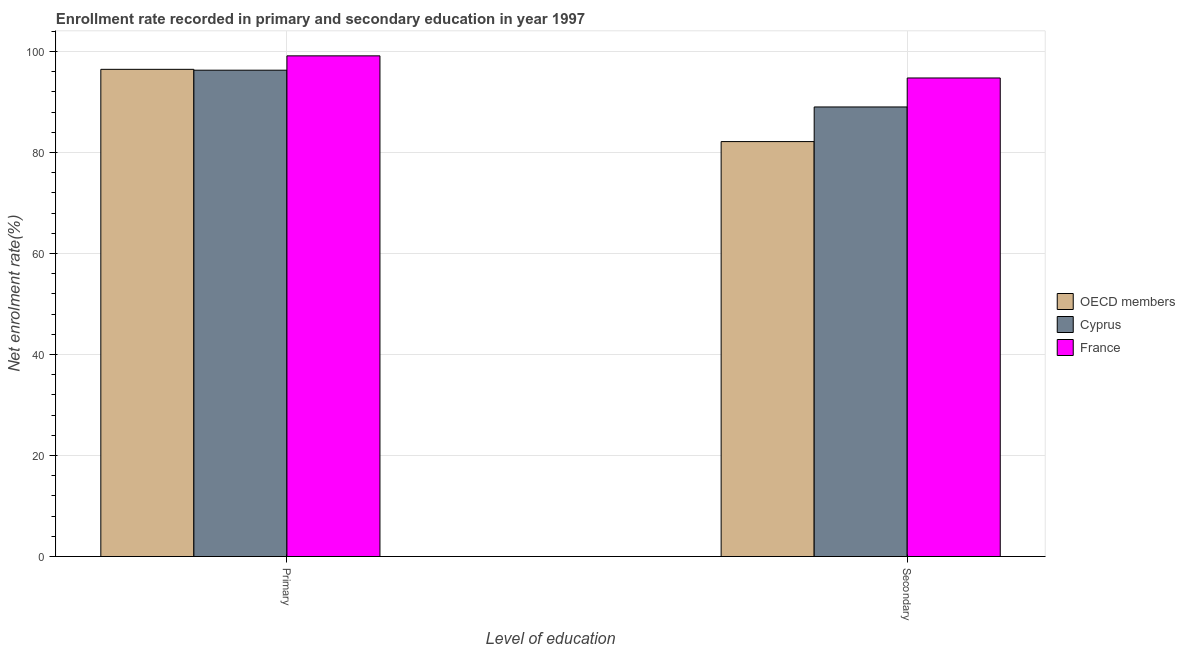How many different coloured bars are there?
Give a very brief answer. 3. How many groups of bars are there?
Offer a terse response. 2. Are the number of bars per tick equal to the number of legend labels?
Your response must be concise. Yes. Are the number of bars on each tick of the X-axis equal?
Your answer should be very brief. Yes. How many bars are there on the 1st tick from the left?
Your answer should be compact. 3. What is the label of the 2nd group of bars from the left?
Offer a terse response. Secondary. What is the enrollment rate in secondary education in OECD members?
Provide a short and direct response. 82.15. Across all countries, what is the maximum enrollment rate in secondary education?
Provide a succinct answer. 94.75. Across all countries, what is the minimum enrollment rate in secondary education?
Ensure brevity in your answer.  82.15. In which country was the enrollment rate in primary education maximum?
Your response must be concise. France. In which country was the enrollment rate in secondary education minimum?
Offer a very short reply. OECD members. What is the total enrollment rate in secondary education in the graph?
Ensure brevity in your answer.  265.9. What is the difference between the enrollment rate in primary education in OECD members and that in France?
Give a very brief answer. -2.67. What is the difference between the enrollment rate in primary education in Cyprus and the enrollment rate in secondary education in France?
Offer a very short reply. 1.54. What is the average enrollment rate in secondary education per country?
Ensure brevity in your answer.  88.63. What is the difference between the enrollment rate in primary education and enrollment rate in secondary education in Cyprus?
Keep it short and to the point. 7.28. In how many countries, is the enrollment rate in primary education greater than 20 %?
Your answer should be very brief. 3. What is the ratio of the enrollment rate in secondary education in Cyprus to that in France?
Provide a short and direct response. 0.94. Is the enrollment rate in secondary education in France less than that in OECD members?
Your answer should be compact. No. Are all the bars in the graph horizontal?
Give a very brief answer. No. How many countries are there in the graph?
Provide a short and direct response. 3. What is the difference between two consecutive major ticks on the Y-axis?
Provide a succinct answer. 20. Does the graph contain any zero values?
Your answer should be very brief. No. Where does the legend appear in the graph?
Provide a succinct answer. Center right. How are the legend labels stacked?
Make the answer very short. Vertical. What is the title of the graph?
Keep it short and to the point. Enrollment rate recorded in primary and secondary education in year 1997. What is the label or title of the X-axis?
Your answer should be very brief. Level of education. What is the label or title of the Y-axis?
Give a very brief answer. Net enrolment rate(%). What is the Net enrolment rate(%) of OECD members in Primary?
Offer a terse response. 96.46. What is the Net enrolment rate(%) of Cyprus in Primary?
Keep it short and to the point. 96.28. What is the Net enrolment rate(%) in France in Primary?
Give a very brief answer. 99.12. What is the Net enrolment rate(%) in OECD members in Secondary?
Your answer should be very brief. 82.15. What is the Net enrolment rate(%) of Cyprus in Secondary?
Give a very brief answer. 89.01. What is the Net enrolment rate(%) in France in Secondary?
Your answer should be very brief. 94.75. Across all Level of education, what is the maximum Net enrolment rate(%) in OECD members?
Ensure brevity in your answer.  96.46. Across all Level of education, what is the maximum Net enrolment rate(%) of Cyprus?
Your answer should be very brief. 96.28. Across all Level of education, what is the maximum Net enrolment rate(%) in France?
Provide a succinct answer. 99.12. Across all Level of education, what is the minimum Net enrolment rate(%) of OECD members?
Offer a terse response. 82.15. Across all Level of education, what is the minimum Net enrolment rate(%) in Cyprus?
Your answer should be compact. 89.01. Across all Level of education, what is the minimum Net enrolment rate(%) of France?
Your answer should be compact. 94.75. What is the total Net enrolment rate(%) in OECD members in the graph?
Offer a very short reply. 178.61. What is the total Net enrolment rate(%) of Cyprus in the graph?
Your response must be concise. 185.29. What is the total Net enrolment rate(%) of France in the graph?
Keep it short and to the point. 193.87. What is the difference between the Net enrolment rate(%) of OECD members in Primary and that in Secondary?
Your answer should be compact. 14.3. What is the difference between the Net enrolment rate(%) of Cyprus in Primary and that in Secondary?
Your answer should be very brief. 7.28. What is the difference between the Net enrolment rate(%) of France in Primary and that in Secondary?
Provide a short and direct response. 4.38. What is the difference between the Net enrolment rate(%) of OECD members in Primary and the Net enrolment rate(%) of Cyprus in Secondary?
Ensure brevity in your answer.  7.45. What is the difference between the Net enrolment rate(%) of OECD members in Primary and the Net enrolment rate(%) of France in Secondary?
Ensure brevity in your answer.  1.71. What is the difference between the Net enrolment rate(%) in Cyprus in Primary and the Net enrolment rate(%) in France in Secondary?
Ensure brevity in your answer.  1.54. What is the average Net enrolment rate(%) of OECD members per Level of education?
Your answer should be very brief. 89.3. What is the average Net enrolment rate(%) of Cyprus per Level of education?
Provide a succinct answer. 92.65. What is the average Net enrolment rate(%) of France per Level of education?
Your answer should be compact. 96.94. What is the difference between the Net enrolment rate(%) in OECD members and Net enrolment rate(%) in Cyprus in Primary?
Your response must be concise. 0.17. What is the difference between the Net enrolment rate(%) in OECD members and Net enrolment rate(%) in France in Primary?
Provide a succinct answer. -2.67. What is the difference between the Net enrolment rate(%) of Cyprus and Net enrolment rate(%) of France in Primary?
Your response must be concise. -2.84. What is the difference between the Net enrolment rate(%) in OECD members and Net enrolment rate(%) in Cyprus in Secondary?
Your answer should be very brief. -6.85. What is the difference between the Net enrolment rate(%) in OECD members and Net enrolment rate(%) in France in Secondary?
Make the answer very short. -12.59. What is the difference between the Net enrolment rate(%) of Cyprus and Net enrolment rate(%) of France in Secondary?
Make the answer very short. -5.74. What is the ratio of the Net enrolment rate(%) in OECD members in Primary to that in Secondary?
Your answer should be compact. 1.17. What is the ratio of the Net enrolment rate(%) in Cyprus in Primary to that in Secondary?
Ensure brevity in your answer.  1.08. What is the ratio of the Net enrolment rate(%) in France in Primary to that in Secondary?
Your response must be concise. 1.05. What is the difference between the highest and the second highest Net enrolment rate(%) in OECD members?
Make the answer very short. 14.3. What is the difference between the highest and the second highest Net enrolment rate(%) in Cyprus?
Your response must be concise. 7.28. What is the difference between the highest and the second highest Net enrolment rate(%) of France?
Ensure brevity in your answer.  4.38. What is the difference between the highest and the lowest Net enrolment rate(%) in OECD members?
Ensure brevity in your answer.  14.3. What is the difference between the highest and the lowest Net enrolment rate(%) in Cyprus?
Your response must be concise. 7.28. What is the difference between the highest and the lowest Net enrolment rate(%) in France?
Keep it short and to the point. 4.38. 